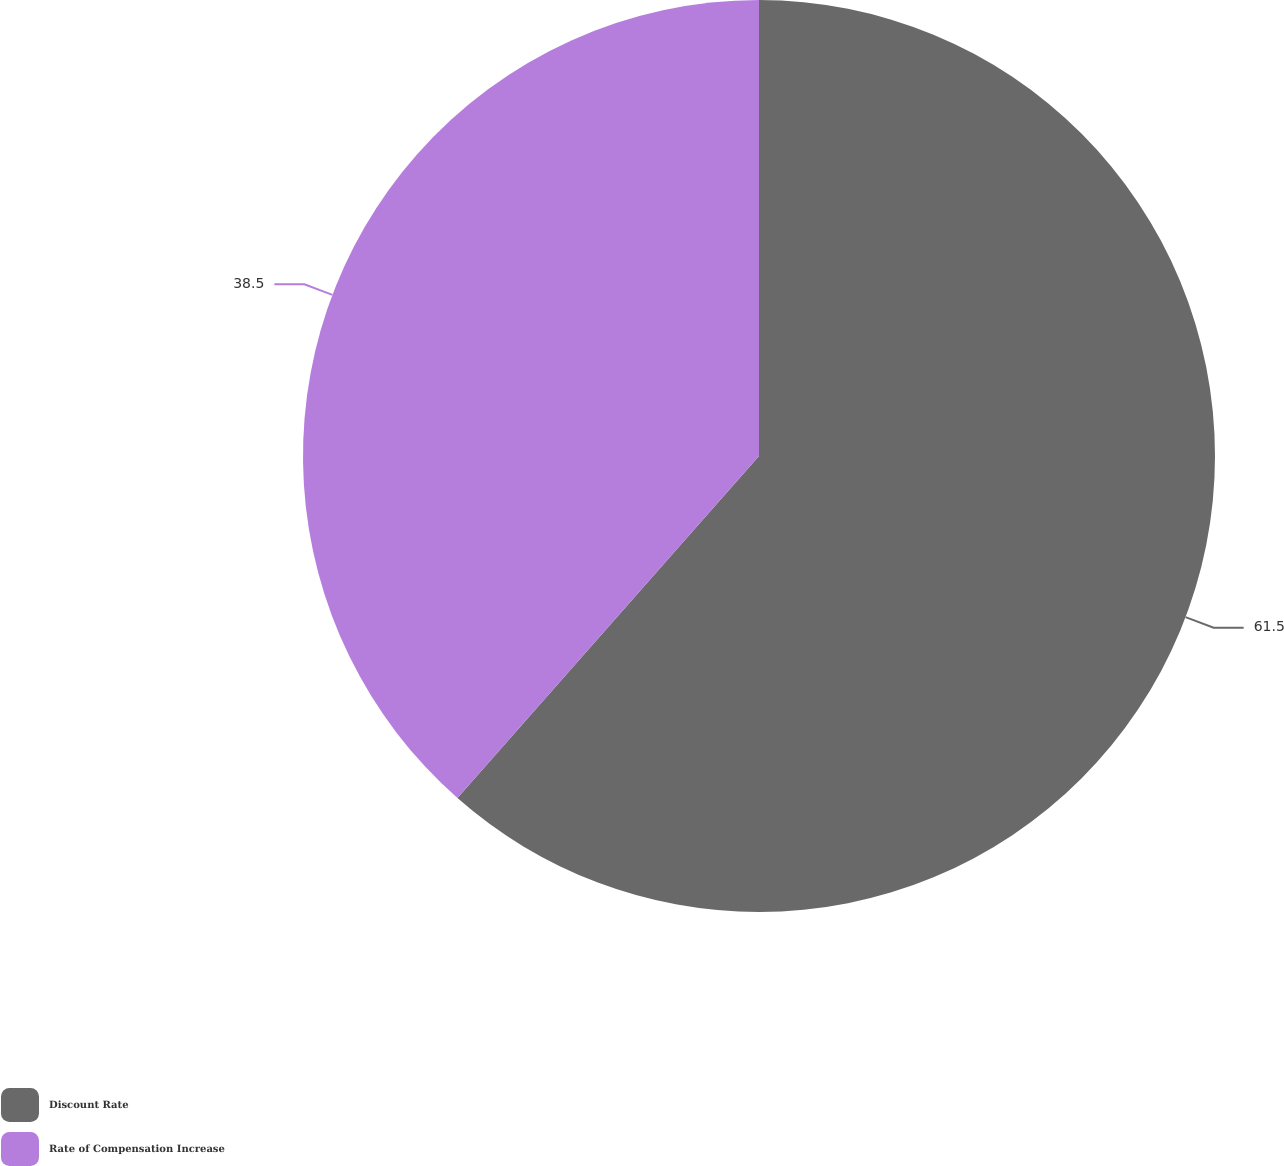Convert chart to OTSL. <chart><loc_0><loc_0><loc_500><loc_500><pie_chart><fcel>Discount Rate<fcel>Rate of Compensation Increase<nl><fcel>61.5%<fcel>38.5%<nl></chart> 